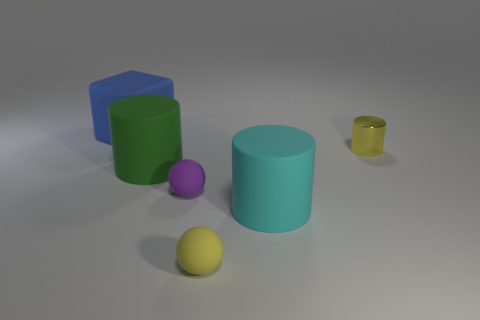Add 1 tiny purple objects. How many objects exist? 7 Subtract all green cylinders. How many cylinders are left? 2 Subtract all shiny cylinders. How many cylinders are left? 2 Add 6 yellow balls. How many yellow balls are left? 7 Add 4 purple objects. How many purple objects exist? 5 Subtract 0 red cylinders. How many objects are left? 6 Subtract all blocks. How many objects are left? 5 Subtract all red cylinders. Subtract all cyan spheres. How many cylinders are left? 3 Subtract all blue balls. How many yellow cylinders are left? 1 Subtract all small red metal cylinders. Subtract all large cyan matte things. How many objects are left? 5 